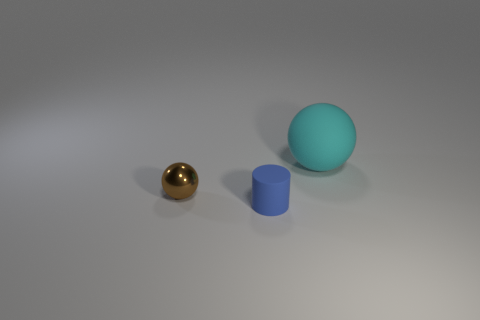There is a cyan matte ball; are there any tiny blue rubber cylinders in front of it?
Ensure brevity in your answer.  Yes. There is a blue cylinder; is its size the same as the ball in front of the large cyan thing?
Offer a very short reply. Yes. What size is the other thing that is the same shape as the small brown thing?
Your answer should be compact. Large. Is there any other thing that is made of the same material as the blue object?
Keep it short and to the point. Yes. Is the size of the matte object in front of the tiny sphere the same as the ball that is on the right side of the small blue cylinder?
Your response must be concise. No. How many tiny objects are either cyan metallic spheres or cyan balls?
Give a very brief answer. 0. What number of things are both behind the matte cylinder and right of the tiny metallic object?
Ensure brevity in your answer.  1. Are the tiny blue object and the ball that is on the left side of the large rubber sphere made of the same material?
Your response must be concise. No. What number of brown objects are either small cylinders or big things?
Provide a succinct answer. 0. Is there a red matte cube of the same size as the metallic ball?
Provide a succinct answer. No. 